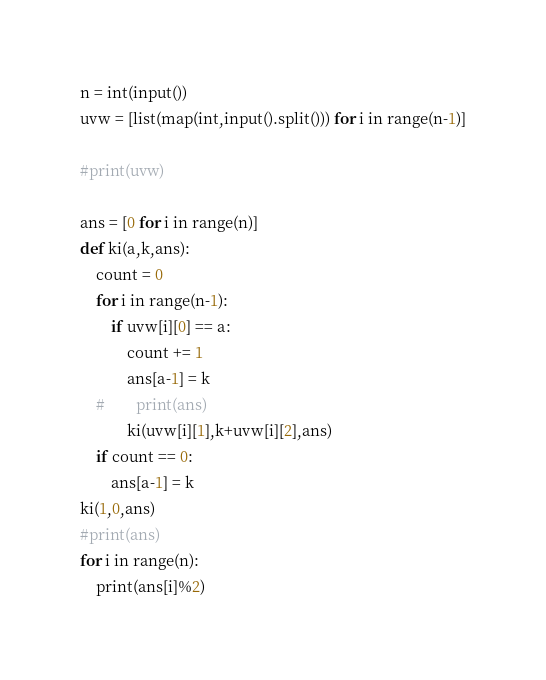Convert code to text. <code><loc_0><loc_0><loc_500><loc_500><_Python_>n = int(input())
uvw = [list(map(int,input().split())) for i in range(n-1)]

#print(uvw)

ans = [0 for i in range(n)]
def ki(a,k,ans):
    count = 0
    for i in range(n-1):
        if uvw[i][0] == a:
            count += 1
            ans[a-1] = k
    #        print(ans)
            ki(uvw[i][1],k+uvw[i][2],ans)
    if count == 0:
        ans[a-1] = k
ki(1,0,ans)
#print(ans)
for i in range(n):
    print(ans[i]%2)</code> 